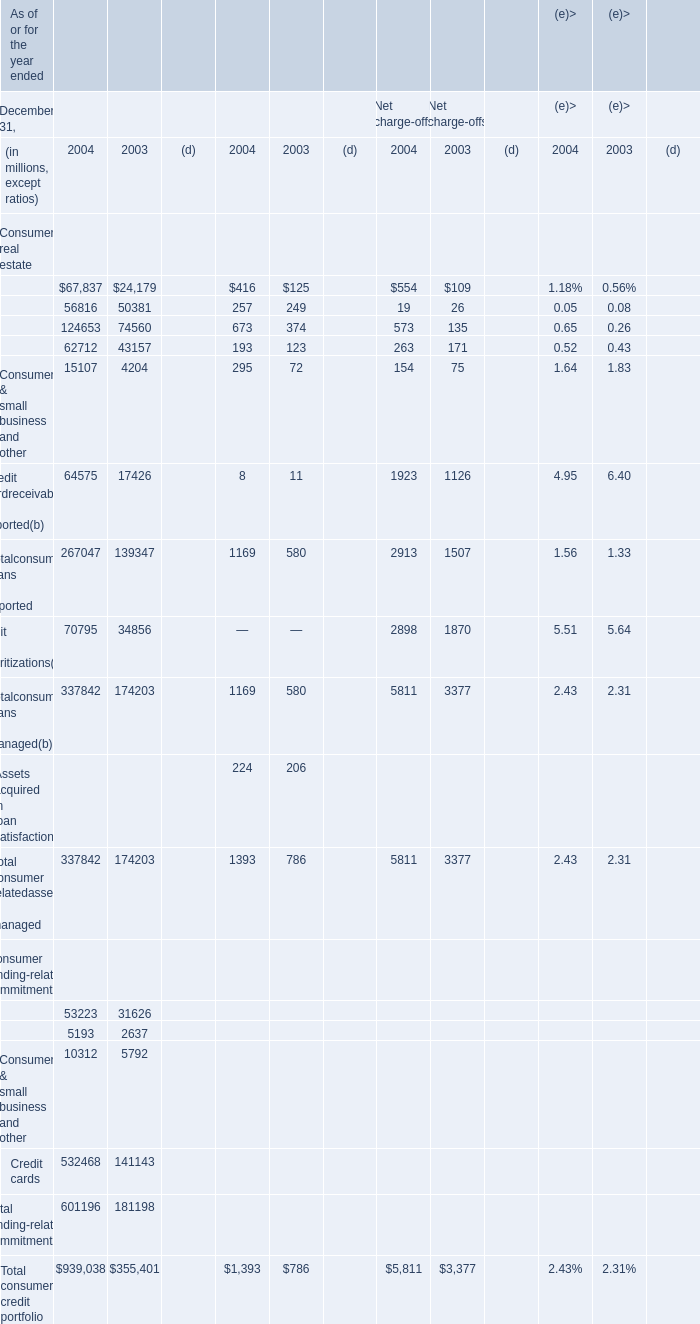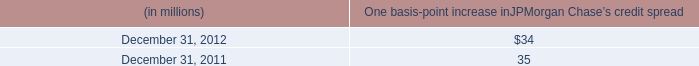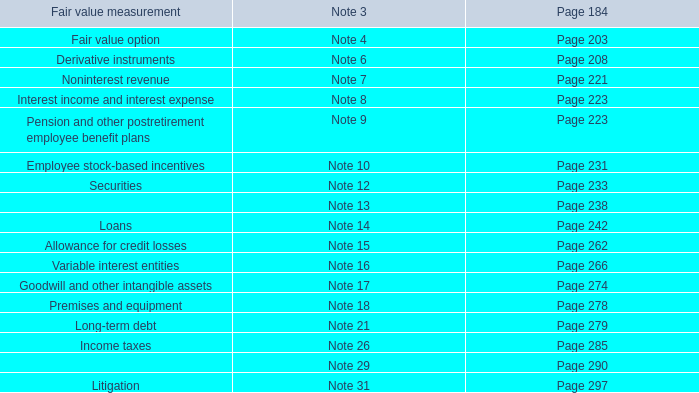how often did the firm sustain losses that exceeded the var measure? 
Computations: (3 / 261)
Answer: 0.01149. 